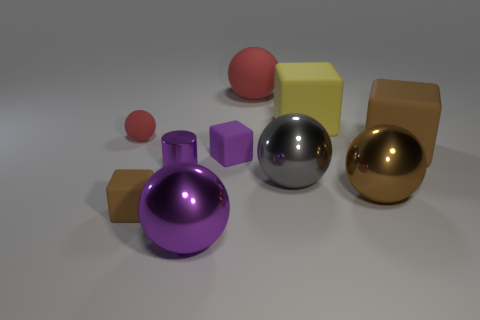Subtract all large purple shiny balls. How many balls are left? 4 Subtract all yellow cylinders. How many brown cubes are left? 2 Subtract all purple balls. How many balls are left? 4 Subtract 3 spheres. How many spheres are left? 2 Subtract all cylinders. How many objects are left? 9 Subtract 0 cyan balls. How many objects are left? 10 Subtract all green blocks. Subtract all cyan cylinders. How many blocks are left? 4 Subtract all tiny purple cubes. Subtract all large brown spheres. How many objects are left? 8 Add 1 large blocks. How many large blocks are left? 3 Add 9 small spheres. How many small spheres exist? 10 